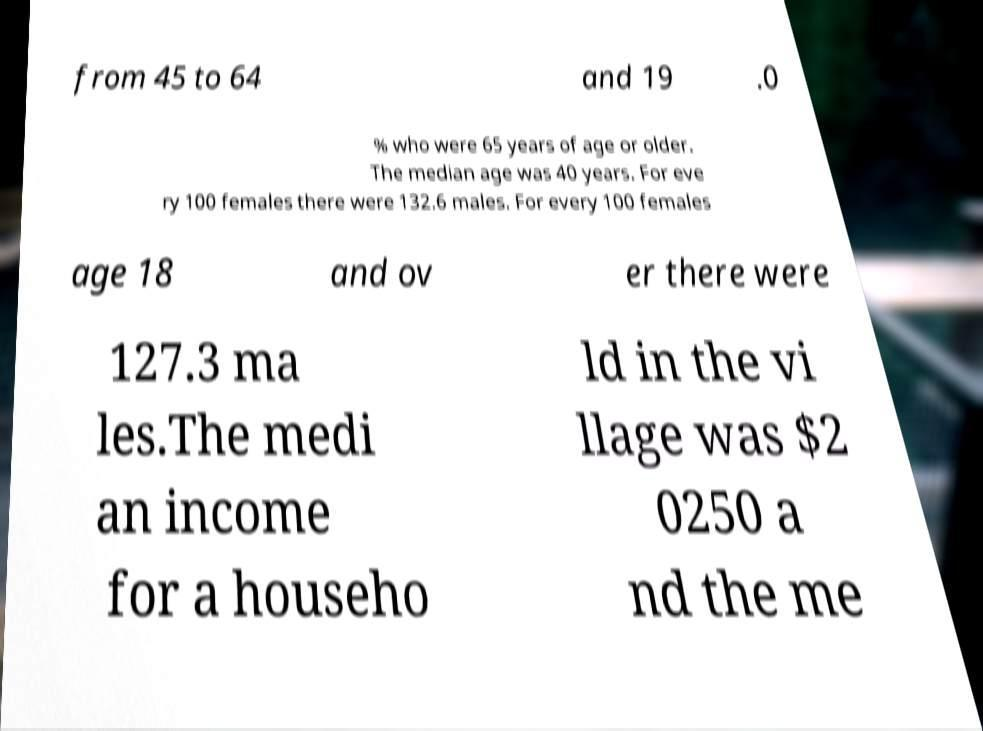Could you extract and type out the text from this image? from 45 to 64 and 19 .0 % who were 65 years of age or older. The median age was 40 years. For eve ry 100 females there were 132.6 males. For every 100 females age 18 and ov er there were 127.3 ma les.The medi an income for a househo ld in the vi llage was $2 0250 a nd the me 